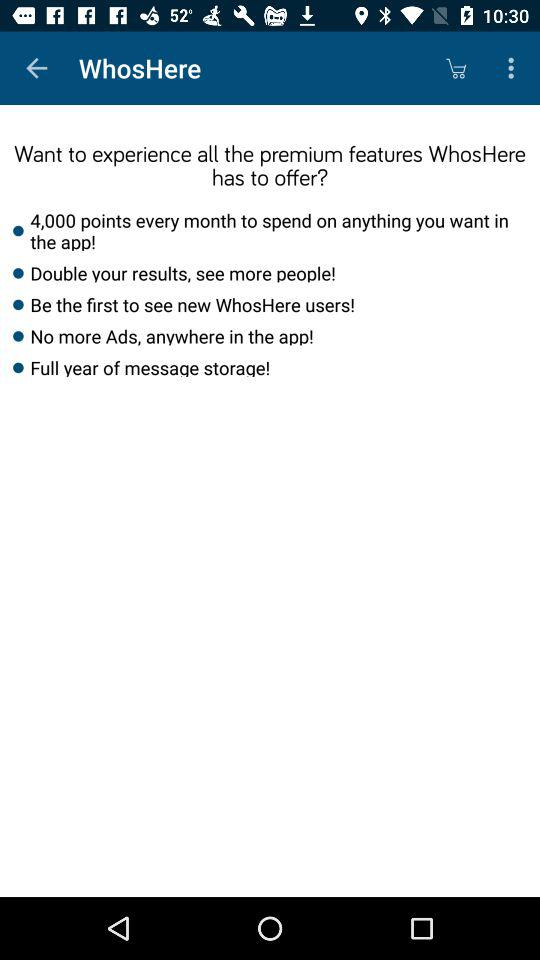How many points are offered per month?
Answer the question using a single word or phrase. 4,000 